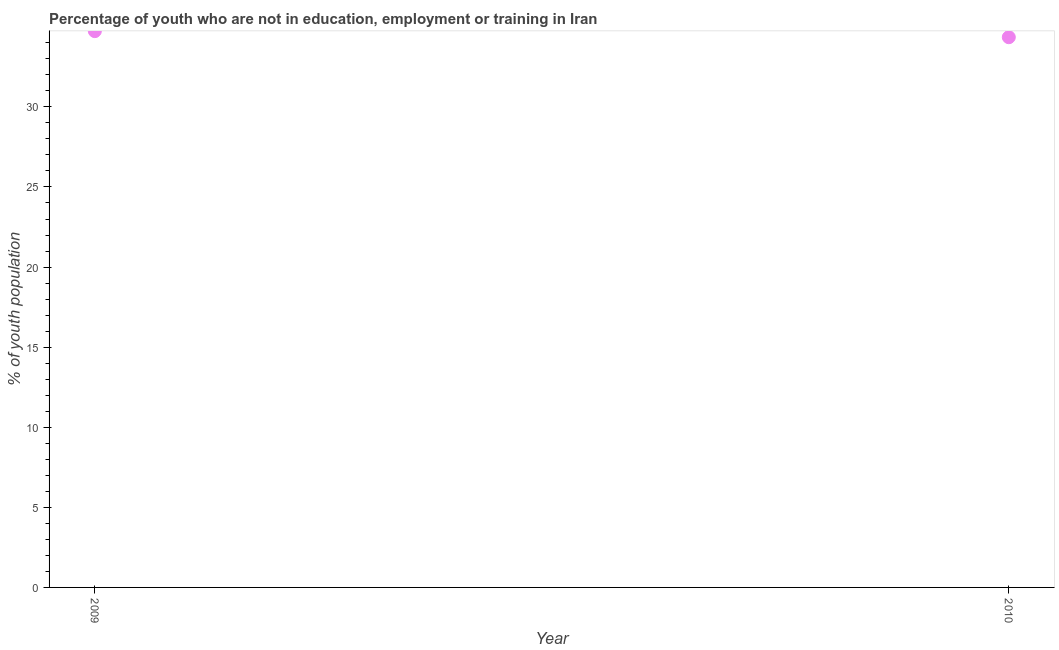What is the unemployed youth population in 2010?
Your answer should be compact. 34.35. Across all years, what is the maximum unemployed youth population?
Ensure brevity in your answer.  34.73. Across all years, what is the minimum unemployed youth population?
Provide a succinct answer. 34.35. In which year was the unemployed youth population maximum?
Provide a short and direct response. 2009. What is the sum of the unemployed youth population?
Provide a succinct answer. 69.08. What is the difference between the unemployed youth population in 2009 and 2010?
Give a very brief answer. 0.38. What is the average unemployed youth population per year?
Ensure brevity in your answer.  34.54. What is the median unemployed youth population?
Ensure brevity in your answer.  34.54. In how many years, is the unemployed youth population greater than 18 %?
Your answer should be compact. 2. What is the ratio of the unemployed youth population in 2009 to that in 2010?
Make the answer very short. 1.01. Is the unemployed youth population in 2009 less than that in 2010?
Offer a terse response. No. Does the unemployed youth population monotonically increase over the years?
Ensure brevity in your answer.  No. How many dotlines are there?
Give a very brief answer. 1. How many years are there in the graph?
Ensure brevity in your answer.  2. What is the difference between two consecutive major ticks on the Y-axis?
Provide a succinct answer. 5. Are the values on the major ticks of Y-axis written in scientific E-notation?
Provide a succinct answer. No. Does the graph contain any zero values?
Make the answer very short. No. What is the title of the graph?
Keep it short and to the point. Percentage of youth who are not in education, employment or training in Iran. What is the label or title of the X-axis?
Offer a terse response. Year. What is the label or title of the Y-axis?
Make the answer very short. % of youth population. What is the % of youth population in 2009?
Your response must be concise. 34.73. What is the % of youth population in 2010?
Provide a succinct answer. 34.35. What is the difference between the % of youth population in 2009 and 2010?
Offer a very short reply. 0.38. What is the ratio of the % of youth population in 2009 to that in 2010?
Provide a short and direct response. 1.01. 